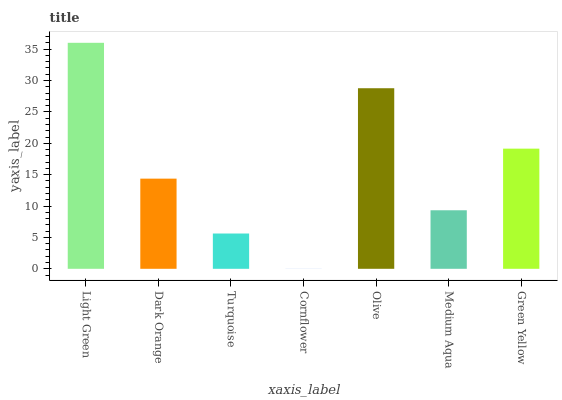Is Cornflower the minimum?
Answer yes or no. Yes. Is Light Green the maximum?
Answer yes or no. Yes. Is Dark Orange the minimum?
Answer yes or no. No. Is Dark Orange the maximum?
Answer yes or no. No. Is Light Green greater than Dark Orange?
Answer yes or no. Yes. Is Dark Orange less than Light Green?
Answer yes or no. Yes. Is Dark Orange greater than Light Green?
Answer yes or no. No. Is Light Green less than Dark Orange?
Answer yes or no. No. Is Dark Orange the high median?
Answer yes or no. Yes. Is Dark Orange the low median?
Answer yes or no. Yes. Is Green Yellow the high median?
Answer yes or no. No. Is Green Yellow the low median?
Answer yes or no. No. 